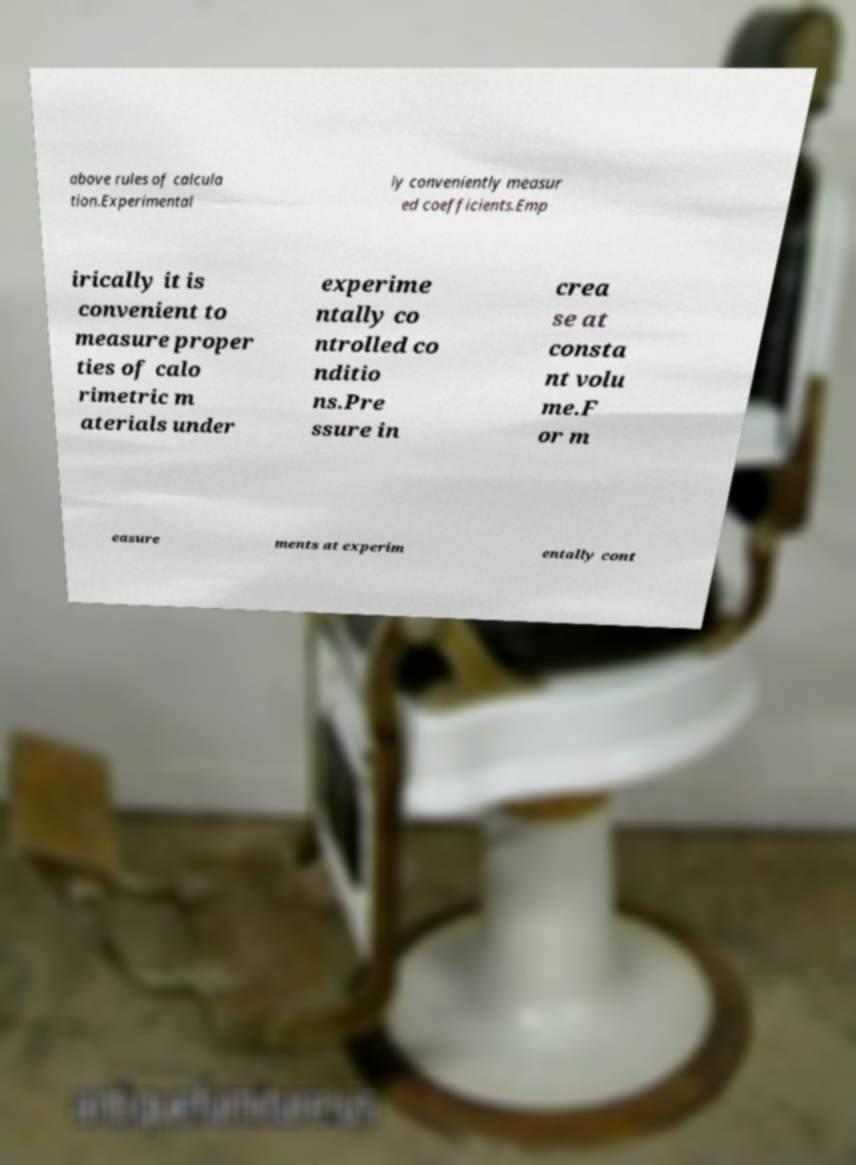There's text embedded in this image that I need extracted. Can you transcribe it verbatim? above rules of calcula tion.Experimental ly conveniently measur ed coefficients.Emp irically it is convenient to measure proper ties of calo rimetric m aterials under experime ntally co ntrolled co nditio ns.Pre ssure in crea se at consta nt volu me.F or m easure ments at experim entally cont 